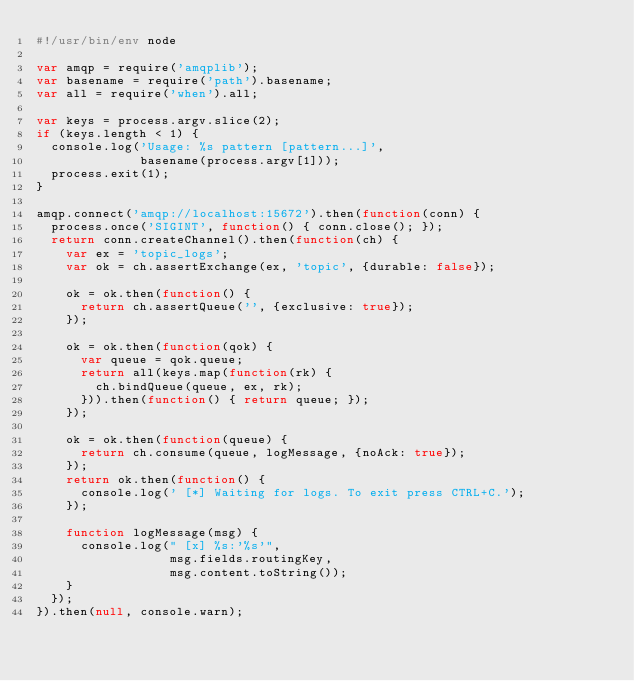<code> <loc_0><loc_0><loc_500><loc_500><_JavaScript_>#!/usr/bin/env node

var amqp = require('amqplib');
var basename = require('path').basename;
var all = require('when').all;

var keys = process.argv.slice(2);
if (keys.length < 1) {
  console.log('Usage: %s pattern [pattern...]',
              basename(process.argv[1]));
  process.exit(1);
}

amqp.connect('amqp://localhost:15672').then(function(conn) {
  process.once('SIGINT', function() { conn.close(); });
  return conn.createChannel().then(function(ch) {
    var ex = 'topic_logs';
    var ok = ch.assertExchange(ex, 'topic', {durable: false});
    
    ok = ok.then(function() {
      return ch.assertQueue('', {exclusive: true});
    });
    
    ok = ok.then(function(qok) {
      var queue = qok.queue;
      return all(keys.map(function(rk) {
        ch.bindQueue(queue, ex, rk);
      })).then(function() { return queue; });
    });
    
    ok = ok.then(function(queue) {
      return ch.consume(queue, logMessage, {noAck: true});
    });
    return ok.then(function() {
      console.log(' [*] Waiting for logs. To exit press CTRL+C.');
    });
    
    function logMessage(msg) {
      console.log(" [x] %s:'%s'",
                  msg.fields.routingKey,
                  msg.content.toString());
    }
  });
}).then(null, console.warn);
</code> 